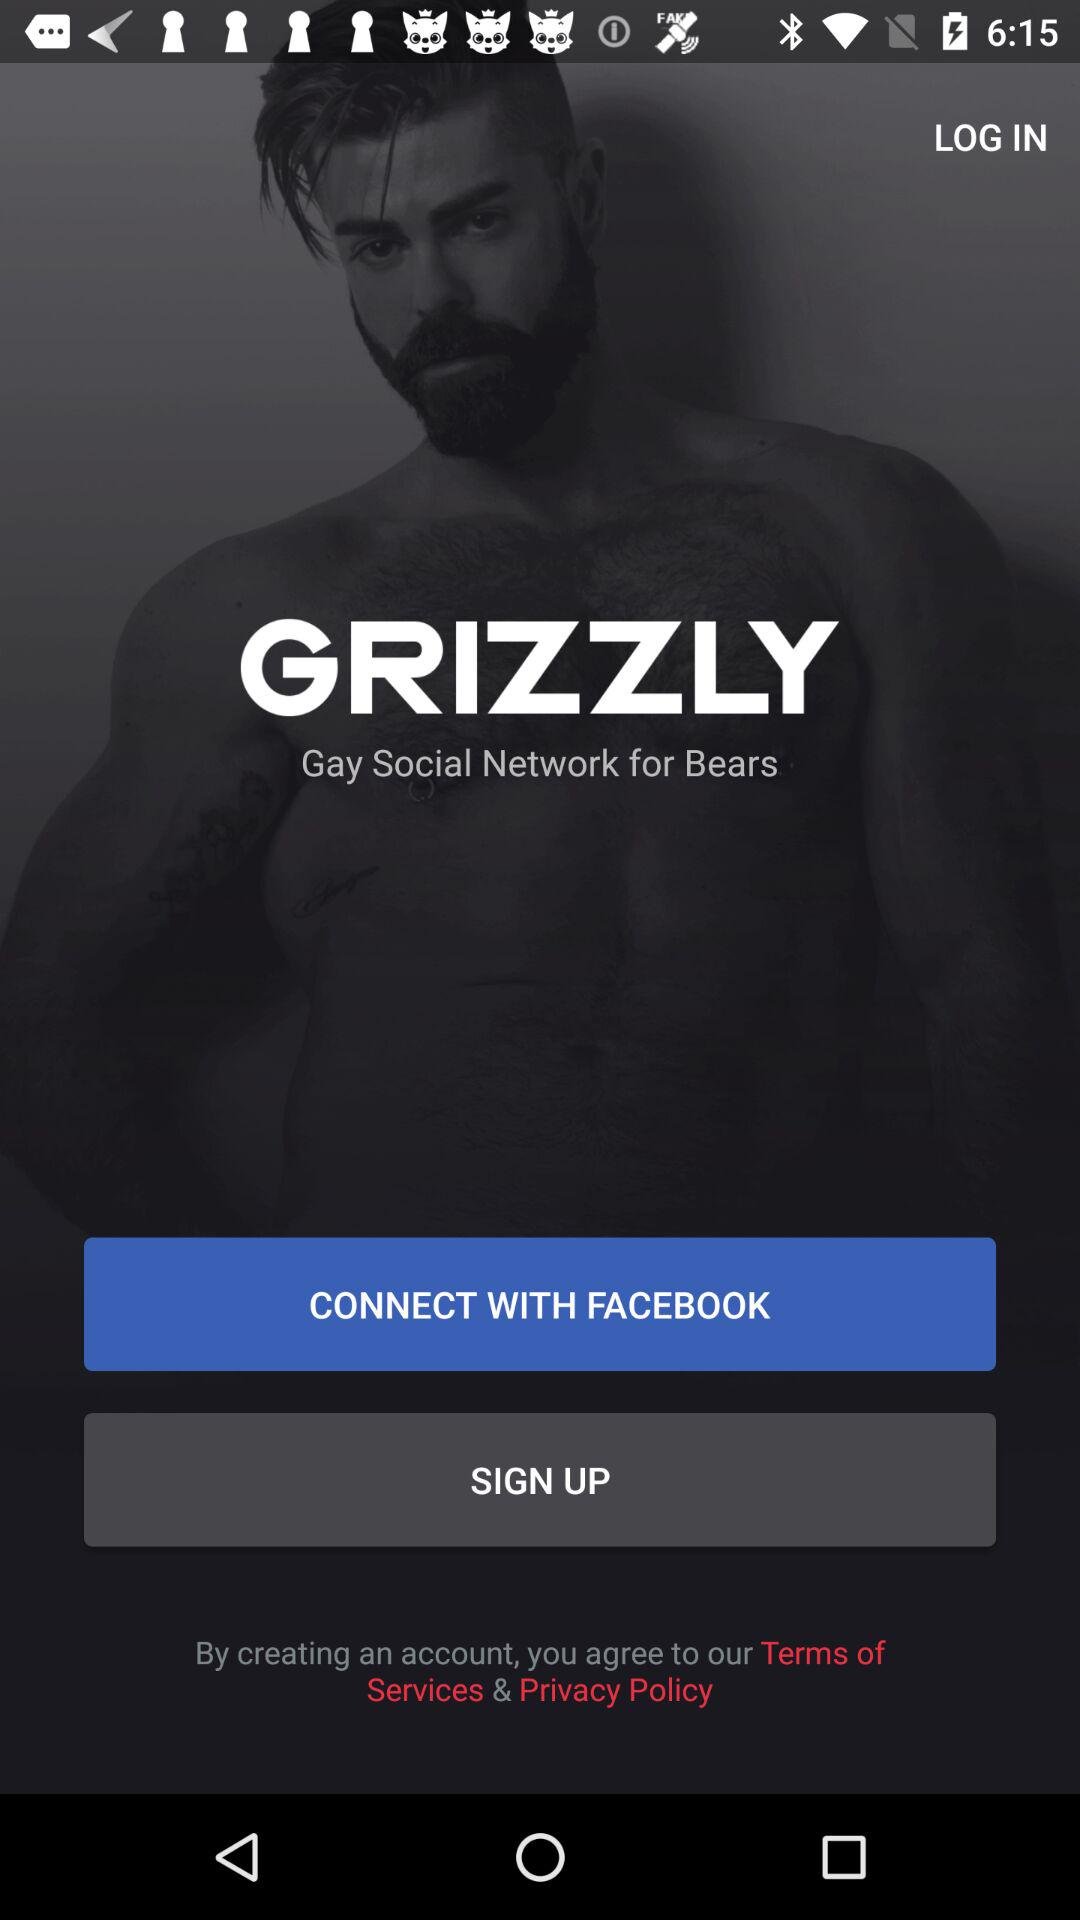What account can I use to sign up? The account that can be used to sign up is "FACEBOOK". 